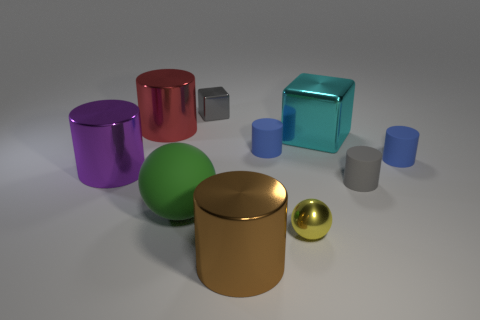Subtract 1 cylinders. How many cylinders are left? 5 Subtract all gray matte cylinders. How many cylinders are left? 5 Subtract all brown cylinders. How many cylinders are left? 5 Subtract all gray cylinders. Subtract all purple blocks. How many cylinders are left? 5 Subtract all cubes. How many objects are left? 8 Subtract all big gray blocks. Subtract all green rubber objects. How many objects are left? 9 Add 7 cyan things. How many cyan things are left? 8 Add 5 large green rubber objects. How many large green rubber objects exist? 6 Subtract 0 cyan cylinders. How many objects are left? 10 